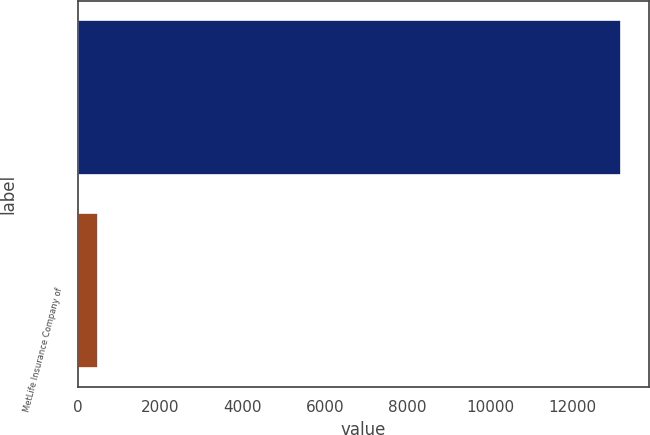Convert chart to OTSL. <chart><loc_0><loc_0><loc_500><loc_500><bar_chart><ecel><fcel>MetLife Insurance Company of<nl><fcel>13184<fcel>500<nl></chart> 